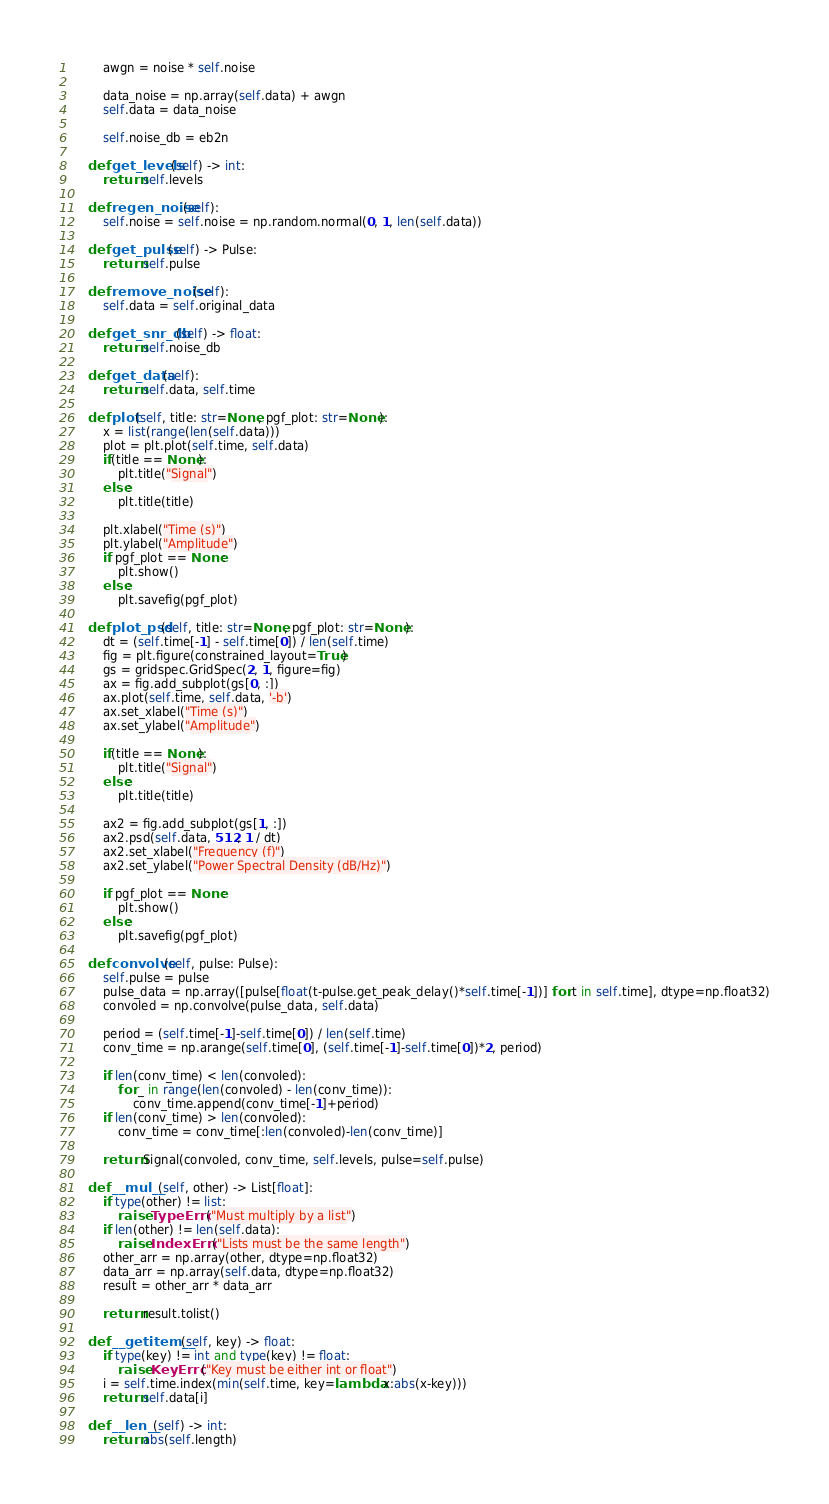Convert code to text. <code><loc_0><loc_0><loc_500><loc_500><_Python_>        awgn = noise * self.noise
        
        data_noise = np.array(self.data) + awgn
        self.data = data_noise
        
        self.noise_db = eb2n

    def get_levels(self) -> int:
        return self.levels

    def regen_noise(self):
        self.noise = self.noise = np.random.normal(0, 1, len(self.data))

    def get_pulse(self) -> Pulse:
        return self.pulse
    
    def remove_noise(self):
        self.data = self.original_data

    def get_snr_db(self) -> float:
        return self.noise_db

    def get_data(self):
        return self.data, self.time

    def plot(self, title: str=None, pgf_plot: str=None):
        x = list(range(len(self.data)))
        plot = plt.plot(self.time, self.data)
        if(title == None):
            plt.title("Signal")
        else:
            plt.title(title)
            
        plt.xlabel("Time (s)")
        plt.ylabel("Amplitude")
        if pgf_plot == None:
            plt.show()
        else:
            plt.savefig(pgf_plot)
    
    def plot_psd(self, title: str=None, pgf_plot: str=None):
        dt = (self.time[-1] - self.time[0]) / len(self.time)
        fig = plt.figure(constrained_layout=True)
        gs = gridspec.GridSpec(2, 1, figure=fig)
        ax = fig.add_subplot(gs[0, :])
        ax.plot(self.time, self.data, '-b')
        ax.set_xlabel("Time (s)")
        ax.set_ylabel("Amplitude")
        
        if(title == None):
            plt.title("Signal")
        else:
            plt.title(title)

        ax2 = fig.add_subplot(gs[1, :])
        ax2.psd(self.data, 512, 1 / dt)
        ax2.set_xlabel("Frequency (f)")
        ax2.set_ylabel("Power Spectral Density (dB/Hz)")

        if pgf_plot == None:
            plt.show()
        else:
            plt.savefig(pgf_plot)

    def convolve(self, pulse: Pulse):
        self.pulse = pulse
        pulse_data = np.array([pulse[float(t-pulse.get_peak_delay()*self.time[-1])] for t in self.time], dtype=np.float32)
        convoled = np.convolve(pulse_data, self.data)
        
        period = (self.time[-1]-self.time[0]) / len(self.time)
        conv_time = np.arange(self.time[0], (self.time[-1]-self.time[0])*2, period)

        if len(conv_time) < len(convoled):
            for _ in range(len(convoled) - len(conv_time)):
                conv_time.append(conv_time[-1]+period)
        if len(conv_time) > len(convoled):
            conv_time = conv_time[:len(convoled)-len(conv_time)]  
        
        return Signal(convoled, conv_time, self.levels, pulse=self.pulse)

    def __mul__(self, other) -> List[float]:
        if type(other) != list:
            raise TypeError("Must multiply by a list")
        if len(other) != len(self.data):
            raise IndexError("Lists must be the same length")
        other_arr = np.array(other, dtype=np.float32)
        data_arr = np.array(self.data, dtype=np.float32)
        result = other_arr * data_arr
        
        return result.tolist()

    def __getitem__(self, key) -> float:
        if type(key) != int and type(key) != float:
            raise KeyError("Key must be either int or float")
        i = self.time.index(min(self.time, key=lambda x:abs(x-key)))
        return self.data[i]

    def __len__(self) -> int:
        return abs(self.length)
</code> 